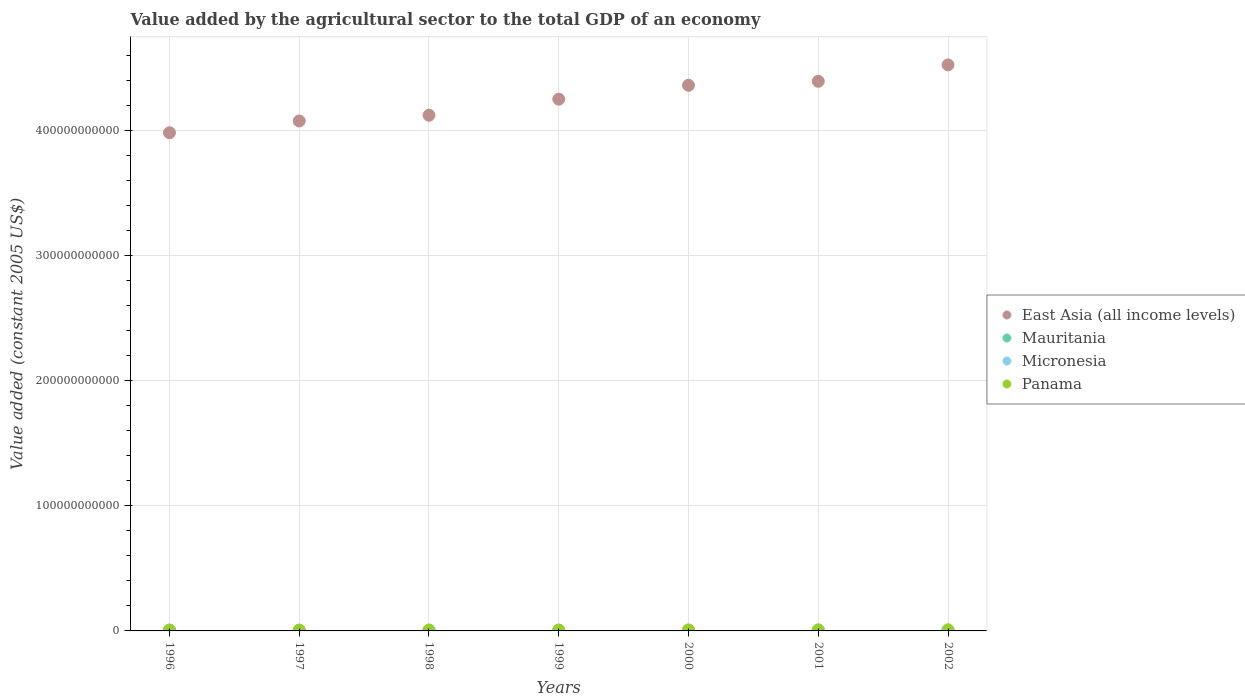What is the value added by the agricultural sector in Panama in 1999?
Provide a short and direct response. 7.35e+08. Across all years, what is the maximum value added by the agricultural sector in Mauritania?
Your answer should be very brief. 6.85e+08. Across all years, what is the minimum value added by the agricultural sector in Panama?
Give a very brief answer. 6.55e+08. In which year was the value added by the agricultural sector in East Asia (all income levels) maximum?
Give a very brief answer. 2002. What is the total value added by the agricultural sector in Mauritania in the graph?
Provide a short and direct response. 4.06e+09. What is the difference between the value added by the agricultural sector in East Asia (all income levels) in 1998 and that in 2001?
Offer a very short reply. -2.71e+1. What is the difference between the value added by the agricultural sector in Mauritania in 1999 and the value added by the agricultural sector in East Asia (all income levels) in 1996?
Provide a short and direct response. -3.97e+11. What is the average value added by the agricultural sector in Micronesia per year?
Provide a succinct answer. 5.56e+07. In the year 1997, what is the difference between the value added by the agricultural sector in East Asia (all income levels) and value added by the agricultural sector in Panama?
Ensure brevity in your answer.  4.07e+11. In how many years, is the value added by the agricultural sector in Micronesia greater than 180000000000 US$?
Provide a short and direct response. 0. What is the ratio of the value added by the agricultural sector in East Asia (all income levels) in 2000 to that in 2001?
Keep it short and to the point. 0.99. What is the difference between the highest and the second highest value added by the agricultural sector in Mauritania?
Give a very brief answer. 1.04e+08. What is the difference between the highest and the lowest value added by the agricultural sector in Panama?
Ensure brevity in your answer.  2.31e+08. Is the sum of the value added by the agricultural sector in Panama in 1999 and 2001 greater than the maximum value added by the agricultural sector in Mauritania across all years?
Your response must be concise. Yes. Does the value added by the agricultural sector in Mauritania monotonically increase over the years?
Your response must be concise. No. Is the value added by the agricultural sector in Panama strictly greater than the value added by the agricultural sector in East Asia (all income levels) over the years?
Your response must be concise. No. What is the difference between two consecutive major ticks on the Y-axis?
Ensure brevity in your answer.  1.00e+11. Does the graph contain any zero values?
Ensure brevity in your answer.  No. Does the graph contain grids?
Ensure brevity in your answer.  Yes. Where does the legend appear in the graph?
Give a very brief answer. Center right. How many legend labels are there?
Provide a succinct answer. 4. What is the title of the graph?
Make the answer very short. Value added by the agricultural sector to the total GDP of an economy. What is the label or title of the Y-axis?
Your response must be concise. Value added (constant 2005 US$). What is the Value added (constant 2005 US$) of East Asia (all income levels) in 1996?
Provide a short and direct response. 3.98e+11. What is the Value added (constant 2005 US$) in Mauritania in 1996?
Provide a short and direct response. 6.85e+08. What is the Value added (constant 2005 US$) of Micronesia in 1996?
Keep it short and to the point. 5.56e+07. What is the Value added (constant 2005 US$) of Panama in 1996?
Make the answer very short. 6.55e+08. What is the Value added (constant 2005 US$) in East Asia (all income levels) in 1997?
Offer a very short reply. 4.07e+11. What is the Value added (constant 2005 US$) in Mauritania in 1997?
Offer a terse response. 5.33e+08. What is the Value added (constant 2005 US$) of Micronesia in 1997?
Offer a terse response. 5.09e+07. What is the Value added (constant 2005 US$) of Panama in 1997?
Provide a short and direct response. 6.77e+08. What is the Value added (constant 2005 US$) of East Asia (all income levels) in 1998?
Keep it short and to the point. 4.12e+11. What is the Value added (constant 2005 US$) of Mauritania in 1998?
Your answer should be compact. 5.41e+08. What is the Value added (constant 2005 US$) of Micronesia in 1998?
Make the answer very short. 5.84e+07. What is the Value added (constant 2005 US$) of Panama in 1998?
Make the answer very short. 7.22e+08. What is the Value added (constant 2005 US$) in East Asia (all income levels) in 1999?
Keep it short and to the point. 4.25e+11. What is the Value added (constant 2005 US$) of Mauritania in 1999?
Ensure brevity in your answer.  5.81e+08. What is the Value added (constant 2005 US$) in Micronesia in 1999?
Give a very brief answer. 5.39e+07. What is the Value added (constant 2005 US$) in Panama in 1999?
Your answer should be compact. 7.35e+08. What is the Value added (constant 2005 US$) in East Asia (all income levels) in 2000?
Ensure brevity in your answer.  4.36e+11. What is the Value added (constant 2005 US$) of Mauritania in 2000?
Give a very brief answer. 5.76e+08. What is the Value added (constant 2005 US$) in Micronesia in 2000?
Make the answer very short. 5.76e+07. What is the Value added (constant 2005 US$) of Panama in 2000?
Offer a terse response. 8.05e+08. What is the Value added (constant 2005 US$) in East Asia (all income levels) in 2001?
Provide a succinct answer. 4.39e+11. What is the Value added (constant 2005 US$) in Mauritania in 2001?
Offer a very short reply. 5.81e+08. What is the Value added (constant 2005 US$) in Micronesia in 2001?
Offer a terse response. 5.57e+07. What is the Value added (constant 2005 US$) in Panama in 2001?
Your response must be concise. 8.57e+08. What is the Value added (constant 2005 US$) in East Asia (all income levels) in 2002?
Your answer should be compact. 4.52e+11. What is the Value added (constant 2005 US$) of Mauritania in 2002?
Keep it short and to the point. 5.64e+08. What is the Value added (constant 2005 US$) of Micronesia in 2002?
Provide a succinct answer. 5.68e+07. What is the Value added (constant 2005 US$) of Panama in 2002?
Make the answer very short. 8.86e+08. Across all years, what is the maximum Value added (constant 2005 US$) of East Asia (all income levels)?
Give a very brief answer. 4.52e+11. Across all years, what is the maximum Value added (constant 2005 US$) in Mauritania?
Offer a very short reply. 6.85e+08. Across all years, what is the maximum Value added (constant 2005 US$) of Micronesia?
Offer a terse response. 5.84e+07. Across all years, what is the maximum Value added (constant 2005 US$) in Panama?
Make the answer very short. 8.86e+08. Across all years, what is the minimum Value added (constant 2005 US$) of East Asia (all income levels)?
Your answer should be very brief. 3.98e+11. Across all years, what is the minimum Value added (constant 2005 US$) in Mauritania?
Provide a succinct answer. 5.33e+08. Across all years, what is the minimum Value added (constant 2005 US$) of Micronesia?
Ensure brevity in your answer.  5.09e+07. Across all years, what is the minimum Value added (constant 2005 US$) in Panama?
Make the answer very short. 6.55e+08. What is the total Value added (constant 2005 US$) in East Asia (all income levels) in the graph?
Your response must be concise. 2.97e+12. What is the total Value added (constant 2005 US$) of Mauritania in the graph?
Ensure brevity in your answer.  4.06e+09. What is the total Value added (constant 2005 US$) in Micronesia in the graph?
Offer a terse response. 3.89e+08. What is the total Value added (constant 2005 US$) of Panama in the graph?
Offer a terse response. 5.34e+09. What is the difference between the Value added (constant 2005 US$) in East Asia (all income levels) in 1996 and that in 1997?
Make the answer very short. -9.41e+09. What is the difference between the Value added (constant 2005 US$) in Mauritania in 1996 and that in 1997?
Your response must be concise. 1.52e+08. What is the difference between the Value added (constant 2005 US$) in Micronesia in 1996 and that in 1997?
Provide a succinct answer. 4.70e+06. What is the difference between the Value added (constant 2005 US$) of Panama in 1996 and that in 1997?
Ensure brevity in your answer.  -2.18e+07. What is the difference between the Value added (constant 2005 US$) in East Asia (all income levels) in 1996 and that in 1998?
Make the answer very short. -1.40e+1. What is the difference between the Value added (constant 2005 US$) of Mauritania in 1996 and that in 1998?
Provide a short and direct response. 1.44e+08. What is the difference between the Value added (constant 2005 US$) of Micronesia in 1996 and that in 1998?
Your response must be concise. -2.75e+06. What is the difference between the Value added (constant 2005 US$) in Panama in 1996 and that in 1998?
Provide a succinct answer. -6.66e+07. What is the difference between the Value added (constant 2005 US$) of East Asia (all income levels) in 1996 and that in 1999?
Ensure brevity in your answer.  -2.68e+1. What is the difference between the Value added (constant 2005 US$) in Mauritania in 1996 and that in 1999?
Your answer should be compact. 1.05e+08. What is the difference between the Value added (constant 2005 US$) of Micronesia in 1996 and that in 1999?
Give a very brief answer. 1.69e+06. What is the difference between the Value added (constant 2005 US$) of Panama in 1996 and that in 1999?
Offer a terse response. -7.96e+07. What is the difference between the Value added (constant 2005 US$) of East Asia (all income levels) in 1996 and that in 2000?
Keep it short and to the point. -3.79e+1. What is the difference between the Value added (constant 2005 US$) of Mauritania in 1996 and that in 2000?
Offer a very short reply. 1.10e+08. What is the difference between the Value added (constant 2005 US$) of Micronesia in 1996 and that in 2000?
Provide a short and direct response. -1.95e+06. What is the difference between the Value added (constant 2005 US$) in Panama in 1996 and that in 2000?
Keep it short and to the point. -1.50e+08. What is the difference between the Value added (constant 2005 US$) of East Asia (all income levels) in 1996 and that in 2001?
Keep it short and to the point. -4.11e+1. What is the difference between the Value added (constant 2005 US$) in Mauritania in 1996 and that in 2001?
Provide a short and direct response. 1.04e+08. What is the difference between the Value added (constant 2005 US$) in Micronesia in 1996 and that in 2001?
Offer a very short reply. -1.52e+04. What is the difference between the Value added (constant 2005 US$) of Panama in 1996 and that in 2001?
Your response must be concise. -2.02e+08. What is the difference between the Value added (constant 2005 US$) in East Asia (all income levels) in 1996 and that in 2002?
Make the answer very short. -5.42e+1. What is the difference between the Value added (constant 2005 US$) in Mauritania in 1996 and that in 2002?
Your response must be concise. 1.22e+08. What is the difference between the Value added (constant 2005 US$) in Micronesia in 1996 and that in 2002?
Ensure brevity in your answer.  -1.13e+06. What is the difference between the Value added (constant 2005 US$) of Panama in 1996 and that in 2002?
Make the answer very short. -2.31e+08. What is the difference between the Value added (constant 2005 US$) of East Asia (all income levels) in 1997 and that in 1998?
Your answer should be very brief. -4.57e+09. What is the difference between the Value added (constant 2005 US$) in Mauritania in 1997 and that in 1998?
Offer a very short reply. -7.94e+06. What is the difference between the Value added (constant 2005 US$) of Micronesia in 1997 and that in 1998?
Your answer should be compact. -7.45e+06. What is the difference between the Value added (constant 2005 US$) of Panama in 1997 and that in 1998?
Provide a succinct answer. -4.48e+07. What is the difference between the Value added (constant 2005 US$) in East Asia (all income levels) in 1997 and that in 1999?
Your answer should be very brief. -1.74e+1. What is the difference between the Value added (constant 2005 US$) in Mauritania in 1997 and that in 1999?
Provide a succinct answer. -4.75e+07. What is the difference between the Value added (constant 2005 US$) in Micronesia in 1997 and that in 1999?
Give a very brief answer. -3.01e+06. What is the difference between the Value added (constant 2005 US$) of Panama in 1997 and that in 1999?
Your answer should be very brief. -5.78e+07. What is the difference between the Value added (constant 2005 US$) of East Asia (all income levels) in 1997 and that in 2000?
Your response must be concise. -2.85e+1. What is the difference between the Value added (constant 2005 US$) of Mauritania in 1997 and that in 2000?
Offer a very short reply. -4.29e+07. What is the difference between the Value added (constant 2005 US$) of Micronesia in 1997 and that in 2000?
Provide a short and direct response. -6.65e+06. What is the difference between the Value added (constant 2005 US$) of Panama in 1997 and that in 2000?
Offer a terse response. -1.28e+08. What is the difference between the Value added (constant 2005 US$) in East Asia (all income levels) in 1997 and that in 2001?
Provide a short and direct response. -3.17e+1. What is the difference between the Value added (constant 2005 US$) of Mauritania in 1997 and that in 2001?
Give a very brief answer. -4.83e+07. What is the difference between the Value added (constant 2005 US$) in Micronesia in 1997 and that in 2001?
Provide a succinct answer. -4.72e+06. What is the difference between the Value added (constant 2005 US$) in Panama in 1997 and that in 2001?
Your answer should be very brief. -1.80e+08. What is the difference between the Value added (constant 2005 US$) in East Asia (all income levels) in 1997 and that in 2002?
Offer a terse response. -4.48e+1. What is the difference between the Value added (constant 2005 US$) in Mauritania in 1997 and that in 2002?
Keep it short and to the point. -3.05e+07. What is the difference between the Value added (constant 2005 US$) of Micronesia in 1997 and that in 2002?
Make the answer very short. -5.83e+06. What is the difference between the Value added (constant 2005 US$) in Panama in 1997 and that in 2002?
Offer a very short reply. -2.09e+08. What is the difference between the Value added (constant 2005 US$) of East Asia (all income levels) in 1998 and that in 1999?
Give a very brief answer. -1.28e+1. What is the difference between the Value added (constant 2005 US$) in Mauritania in 1998 and that in 1999?
Your answer should be compact. -3.96e+07. What is the difference between the Value added (constant 2005 US$) of Micronesia in 1998 and that in 1999?
Make the answer very short. 4.44e+06. What is the difference between the Value added (constant 2005 US$) in Panama in 1998 and that in 1999?
Offer a terse response. -1.29e+07. What is the difference between the Value added (constant 2005 US$) of East Asia (all income levels) in 1998 and that in 2000?
Provide a succinct answer. -2.39e+1. What is the difference between the Value added (constant 2005 US$) of Mauritania in 1998 and that in 2000?
Make the answer very short. -3.49e+07. What is the difference between the Value added (constant 2005 US$) in Micronesia in 1998 and that in 2000?
Provide a short and direct response. 7.99e+05. What is the difference between the Value added (constant 2005 US$) of Panama in 1998 and that in 2000?
Ensure brevity in your answer.  -8.34e+07. What is the difference between the Value added (constant 2005 US$) in East Asia (all income levels) in 1998 and that in 2001?
Your response must be concise. -2.71e+1. What is the difference between the Value added (constant 2005 US$) in Mauritania in 1998 and that in 2001?
Your answer should be compact. -4.03e+07. What is the difference between the Value added (constant 2005 US$) in Micronesia in 1998 and that in 2001?
Your answer should be very brief. 2.73e+06. What is the difference between the Value added (constant 2005 US$) in Panama in 1998 and that in 2001?
Your answer should be very brief. -1.35e+08. What is the difference between the Value added (constant 2005 US$) of East Asia (all income levels) in 1998 and that in 2002?
Give a very brief answer. -4.02e+1. What is the difference between the Value added (constant 2005 US$) in Mauritania in 1998 and that in 2002?
Offer a terse response. -2.25e+07. What is the difference between the Value added (constant 2005 US$) of Micronesia in 1998 and that in 2002?
Offer a terse response. 1.62e+06. What is the difference between the Value added (constant 2005 US$) in Panama in 1998 and that in 2002?
Keep it short and to the point. -1.64e+08. What is the difference between the Value added (constant 2005 US$) of East Asia (all income levels) in 1999 and that in 2000?
Your response must be concise. -1.11e+1. What is the difference between the Value added (constant 2005 US$) in Mauritania in 1999 and that in 2000?
Offer a very short reply. 4.62e+06. What is the difference between the Value added (constant 2005 US$) of Micronesia in 1999 and that in 2000?
Ensure brevity in your answer.  -3.64e+06. What is the difference between the Value added (constant 2005 US$) in Panama in 1999 and that in 2000?
Ensure brevity in your answer.  -7.05e+07. What is the difference between the Value added (constant 2005 US$) of East Asia (all income levels) in 1999 and that in 2001?
Give a very brief answer. -1.43e+1. What is the difference between the Value added (constant 2005 US$) in Mauritania in 1999 and that in 2001?
Give a very brief answer. -7.75e+05. What is the difference between the Value added (constant 2005 US$) of Micronesia in 1999 and that in 2001?
Offer a very short reply. -1.71e+06. What is the difference between the Value added (constant 2005 US$) in Panama in 1999 and that in 2001?
Provide a succinct answer. -1.23e+08. What is the difference between the Value added (constant 2005 US$) of East Asia (all income levels) in 1999 and that in 2002?
Your answer should be compact. -2.74e+1. What is the difference between the Value added (constant 2005 US$) in Mauritania in 1999 and that in 2002?
Provide a short and direct response. 1.70e+07. What is the difference between the Value added (constant 2005 US$) of Micronesia in 1999 and that in 2002?
Your response must be concise. -2.82e+06. What is the difference between the Value added (constant 2005 US$) in Panama in 1999 and that in 2002?
Ensure brevity in your answer.  -1.51e+08. What is the difference between the Value added (constant 2005 US$) of East Asia (all income levels) in 2000 and that in 2001?
Your answer should be compact. -3.18e+09. What is the difference between the Value added (constant 2005 US$) of Mauritania in 2000 and that in 2001?
Provide a short and direct response. -5.39e+06. What is the difference between the Value added (constant 2005 US$) of Micronesia in 2000 and that in 2001?
Ensure brevity in your answer.  1.94e+06. What is the difference between the Value added (constant 2005 US$) of Panama in 2000 and that in 2001?
Your response must be concise. -5.21e+07. What is the difference between the Value added (constant 2005 US$) of East Asia (all income levels) in 2000 and that in 2002?
Your answer should be very brief. -1.63e+1. What is the difference between the Value added (constant 2005 US$) of Mauritania in 2000 and that in 2002?
Your answer should be compact. 1.24e+07. What is the difference between the Value added (constant 2005 US$) in Micronesia in 2000 and that in 2002?
Offer a very short reply. 8.23e+05. What is the difference between the Value added (constant 2005 US$) of Panama in 2000 and that in 2002?
Provide a short and direct response. -8.06e+07. What is the difference between the Value added (constant 2005 US$) in East Asia (all income levels) in 2001 and that in 2002?
Keep it short and to the point. -1.31e+1. What is the difference between the Value added (constant 2005 US$) of Mauritania in 2001 and that in 2002?
Your response must be concise. 1.78e+07. What is the difference between the Value added (constant 2005 US$) in Micronesia in 2001 and that in 2002?
Ensure brevity in your answer.  -1.11e+06. What is the difference between the Value added (constant 2005 US$) of Panama in 2001 and that in 2002?
Offer a terse response. -2.85e+07. What is the difference between the Value added (constant 2005 US$) of East Asia (all income levels) in 1996 and the Value added (constant 2005 US$) of Mauritania in 1997?
Your answer should be compact. 3.97e+11. What is the difference between the Value added (constant 2005 US$) of East Asia (all income levels) in 1996 and the Value added (constant 2005 US$) of Micronesia in 1997?
Offer a terse response. 3.98e+11. What is the difference between the Value added (constant 2005 US$) in East Asia (all income levels) in 1996 and the Value added (constant 2005 US$) in Panama in 1997?
Provide a succinct answer. 3.97e+11. What is the difference between the Value added (constant 2005 US$) in Mauritania in 1996 and the Value added (constant 2005 US$) in Micronesia in 1997?
Offer a very short reply. 6.35e+08. What is the difference between the Value added (constant 2005 US$) in Mauritania in 1996 and the Value added (constant 2005 US$) in Panama in 1997?
Your answer should be compact. 8.34e+06. What is the difference between the Value added (constant 2005 US$) in Micronesia in 1996 and the Value added (constant 2005 US$) in Panama in 1997?
Ensure brevity in your answer.  -6.22e+08. What is the difference between the Value added (constant 2005 US$) of East Asia (all income levels) in 1996 and the Value added (constant 2005 US$) of Mauritania in 1998?
Your response must be concise. 3.97e+11. What is the difference between the Value added (constant 2005 US$) of East Asia (all income levels) in 1996 and the Value added (constant 2005 US$) of Micronesia in 1998?
Your response must be concise. 3.98e+11. What is the difference between the Value added (constant 2005 US$) in East Asia (all income levels) in 1996 and the Value added (constant 2005 US$) in Panama in 1998?
Give a very brief answer. 3.97e+11. What is the difference between the Value added (constant 2005 US$) of Mauritania in 1996 and the Value added (constant 2005 US$) of Micronesia in 1998?
Your answer should be very brief. 6.27e+08. What is the difference between the Value added (constant 2005 US$) of Mauritania in 1996 and the Value added (constant 2005 US$) of Panama in 1998?
Your answer should be very brief. -3.65e+07. What is the difference between the Value added (constant 2005 US$) of Micronesia in 1996 and the Value added (constant 2005 US$) of Panama in 1998?
Your response must be concise. -6.66e+08. What is the difference between the Value added (constant 2005 US$) of East Asia (all income levels) in 1996 and the Value added (constant 2005 US$) of Mauritania in 1999?
Offer a terse response. 3.97e+11. What is the difference between the Value added (constant 2005 US$) of East Asia (all income levels) in 1996 and the Value added (constant 2005 US$) of Micronesia in 1999?
Your response must be concise. 3.98e+11. What is the difference between the Value added (constant 2005 US$) in East Asia (all income levels) in 1996 and the Value added (constant 2005 US$) in Panama in 1999?
Make the answer very short. 3.97e+11. What is the difference between the Value added (constant 2005 US$) in Mauritania in 1996 and the Value added (constant 2005 US$) in Micronesia in 1999?
Your answer should be very brief. 6.32e+08. What is the difference between the Value added (constant 2005 US$) in Mauritania in 1996 and the Value added (constant 2005 US$) in Panama in 1999?
Offer a very short reply. -4.94e+07. What is the difference between the Value added (constant 2005 US$) of Micronesia in 1996 and the Value added (constant 2005 US$) of Panama in 1999?
Ensure brevity in your answer.  -6.79e+08. What is the difference between the Value added (constant 2005 US$) in East Asia (all income levels) in 1996 and the Value added (constant 2005 US$) in Mauritania in 2000?
Ensure brevity in your answer.  3.97e+11. What is the difference between the Value added (constant 2005 US$) in East Asia (all income levels) in 1996 and the Value added (constant 2005 US$) in Micronesia in 2000?
Make the answer very short. 3.98e+11. What is the difference between the Value added (constant 2005 US$) in East Asia (all income levels) in 1996 and the Value added (constant 2005 US$) in Panama in 2000?
Keep it short and to the point. 3.97e+11. What is the difference between the Value added (constant 2005 US$) of Mauritania in 1996 and the Value added (constant 2005 US$) of Micronesia in 2000?
Make the answer very short. 6.28e+08. What is the difference between the Value added (constant 2005 US$) of Mauritania in 1996 and the Value added (constant 2005 US$) of Panama in 2000?
Your answer should be very brief. -1.20e+08. What is the difference between the Value added (constant 2005 US$) in Micronesia in 1996 and the Value added (constant 2005 US$) in Panama in 2000?
Provide a short and direct response. -7.50e+08. What is the difference between the Value added (constant 2005 US$) in East Asia (all income levels) in 1996 and the Value added (constant 2005 US$) in Mauritania in 2001?
Offer a terse response. 3.97e+11. What is the difference between the Value added (constant 2005 US$) in East Asia (all income levels) in 1996 and the Value added (constant 2005 US$) in Micronesia in 2001?
Provide a short and direct response. 3.98e+11. What is the difference between the Value added (constant 2005 US$) in East Asia (all income levels) in 1996 and the Value added (constant 2005 US$) in Panama in 2001?
Offer a terse response. 3.97e+11. What is the difference between the Value added (constant 2005 US$) in Mauritania in 1996 and the Value added (constant 2005 US$) in Micronesia in 2001?
Offer a very short reply. 6.30e+08. What is the difference between the Value added (constant 2005 US$) of Mauritania in 1996 and the Value added (constant 2005 US$) of Panama in 2001?
Offer a very short reply. -1.72e+08. What is the difference between the Value added (constant 2005 US$) of Micronesia in 1996 and the Value added (constant 2005 US$) of Panama in 2001?
Provide a succinct answer. -8.02e+08. What is the difference between the Value added (constant 2005 US$) in East Asia (all income levels) in 1996 and the Value added (constant 2005 US$) in Mauritania in 2002?
Your response must be concise. 3.97e+11. What is the difference between the Value added (constant 2005 US$) in East Asia (all income levels) in 1996 and the Value added (constant 2005 US$) in Micronesia in 2002?
Keep it short and to the point. 3.98e+11. What is the difference between the Value added (constant 2005 US$) of East Asia (all income levels) in 1996 and the Value added (constant 2005 US$) of Panama in 2002?
Provide a short and direct response. 3.97e+11. What is the difference between the Value added (constant 2005 US$) in Mauritania in 1996 and the Value added (constant 2005 US$) in Micronesia in 2002?
Your answer should be very brief. 6.29e+08. What is the difference between the Value added (constant 2005 US$) in Mauritania in 1996 and the Value added (constant 2005 US$) in Panama in 2002?
Ensure brevity in your answer.  -2.00e+08. What is the difference between the Value added (constant 2005 US$) of Micronesia in 1996 and the Value added (constant 2005 US$) of Panama in 2002?
Your answer should be very brief. -8.30e+08. What is the difference between the Value added (constant 2005 US$) of East Asia (all income levels) in 1997 and the Value added (constant 2005 US$) of Mauritania in 1998?
Give a very brief answer. 4.07e+11. What is the difference between the Value added (constant 2005 US$) in East Asia (all income levels) in 1997 and the Value added (constant 2005 US$) in Micronesia in 1998?
Provide a succinct answer. 4.07e+11. What is the difference between the Value added (constant 2005 US$) of East Asia (all income levels) in 1997 and the Value added (constant 2005 US$) of Panama in 1998?
Your answer should be compact. 4.07e+11. What is the difference between the Value added (constant 2005 US$) of Mauritania in 1997 and the Value added (constant 2005 US$) of Micronesia in 1998?
Make the answer very short. 4.75e+08. What is the difference between the Value added (constant 2005 US$) in Mauritania in 1997 and the Value added (constant 2005 US$) in Panama in 1998?
Give a very brief answer. -1.89e+08. What is the difference between the Value added (constant 2005 US$) of Micronesia in 1997 and the Value added (constant 2005 US$) of Panama in 1998?
Ensure brevity in your answer.  -6.71e+08. What is the difference between the Value added (constant 2005 US$) in East Asia (all income levels) in 1997 and the Value added (constant 2005 US$) in Mauritania in 1999?
Offer a very short reply. 4.07e+11. What is the difference between the Value added (constant 2005 US$) of East Asia (all income levels) in 1997 and the Value added (constant 2005 US$) of Micronesia in 1999?
Your answer should be very brief. 4.07e+11. What is the difference between the Value added (constant 2005 US$) in East Asia (all income levels) in 1997 and the Value added (constant 2005 US$) in Panama in 1999?
Provide a short and direct response. 4.07e+11. What is the difference between the Value added (constant 2005 US$) of Mauritania in 1997 and the Value added (constant 2005 US$) of Micronesia in 1999?
Make the answer very short. 4.79e+08. What is the difference between the Value added (constant 2005 US$) in Mauritania in 1997 and the Value added (constant 2005 US$) in Panama in 1999?
Your answer should be very brief. -2.02e+08. What is the difference between the Value added (constant 2005 US$) of Micronesia in 1997 and the Value added (constant 2005 US$) of Panama in 1999?
Provide a succinct answer. -6.84e+08. What is the difference between the Value added (constant 2005 US$) in East Asia (all income levels) in 1997 and the Value added (constant 2005 US$) in Mauritania in 2000?
Give a very brief answer. 4.07e+11. What is the difference between the Value added (constant 2005 US$) of East Asia (all income levels) in 1997 and the Value added (constant 2005 US$) of Micronesia in 2000?
Offer a terse response. 4.07e+11. What is the difference between the Value added (constant 2005 US$) in East Asia (all income levels) in 1997 and the Value added (constant 2005 US$) in Panama in 2000?
Give a very brief answer. 4.07e+11. What is the difference between the Value added (constant 2005 US$) of Mauritania in 1997 and the Value added (constant 2005 US$) of Micronesia in 2000?
Your response must be concise. 4.76e+08. What is the difference between the Value added (constant 2005 US$) in Mauritania in 1997 and the Value added (constant 2005 US$) in Panama in 2000?
Offer a terse response. -2.72e+08. What is the difference between the Value added (constant 2005 US$) in Micronesia in 1997 and the Value added (constant 2005 US$) in Panama in 2000?
Your answer should be compact. -7.54e+08. What is the difference between the Value added (constant 2005 US$) of East Asia (all income levels) in 1997 and the Value added (constant 2005 US$) of Mauritania in 2001?
Provide a short and direct response. 4.07e+11. What is the difference between the Value added (constant 2005 US$) of East Asia (all income levels) in 1997 and the Value added (constant 2005 US$) of Micronesia in 2001?
Offer a terse response. 4.07e+11. What is the difference between the Value added (constant 2005 US$) in East Asia (all income levels) in 1997 and the Value added (constant 2005 US$) in Panama in 2001?
Offer a very short reply. 4.06e+11. What is the difference between the Value added (constant 2005 US$) of Mauritania in 1997 and the Value added (constant 2005 US$) of Micronesia in 2001?
Keep it short and to the point. 4.77e+08. What is the difference between the Value added (constant 2005 US$) of Mauritania in 1997 and the Value added (constant 2005 US$) of Panama in 2001?
Your answer should be very brief. -3.24e+08. What is the difference between the Value added (constant 2005 US$) in Micronesia in 1997 and the Value added (constant 2005 US$) in Panama in 2001?
Make the answer very short. -8.07e+08. What is the difference between the Value added (constant 2005 US$) in East Asia (all income levels) in 1997 and the Value added (constant 2005 US$) in Mauritania in 2002?
Provide a short and direct response. 4.07e+11. What is the difference between the Value added (constant 2005 US$) of East Asia (all income levels) in 1997 and the Value added (constant 2005 US$) of Micronesia in 2002?
Offer a terse response. 4.07e+11. What is the difference between the Value added (constant 2005 US$) of East Asia (all income levels) in 1997 and the Value added (constant 2005 US$) of Panama in 2002?
Your answer should be very brief. 4.06e+11. What is the difference between the Value added (constant 2005 US$) in Mauritania in 1997 and the Value added (constant 2005 US$) in Micronesia in 2002?
Give a very brief answer. 4.76e+08. What is the difference between the Value added (constant 2005 US$) of Mauritania in 1997 and the Value added (constant 2005 US$) of Panama in 2002?
Provide a short and direct response. -3.53e+08. What is the difference between the Value added (constant 2005 US$) of Micronesia in 1997 and the Value added (constant 2005 US$) of Panama in 2002?
Your response must be concise. -8.35e+08. What is the difference between the Value added (constant 2005 US$) of East Asia (all income levels) in 1998 and the Value added (constant 2005 US$) of Mauritania in 1999?
Your response must be concise. 4.11e+11. What is the difference between the Value added (constant 2005 US$) in East Asia (all income levels) in 1998 and the Value added (constant 2005 US$) in Micronesia in 1999?
Offer a very short reply. 4.12e+11. What is the difference between the Value added (constant 2005 US$) in East Asia (all income levels) in 1998 and the Value added (constant 2005 US$) in Panama in 1999?
Your answer should be compact. 4.11e+11. What is the difference between the Value added (constant 2005 US$) in Mauritania in 1998 and the Value added (constant 2005 US$) in Micronesia in 1999?
Provide a short and direct response. 4.87e+08. What is the difference between the Value added (constant 2005 US$) of Mauritania in 1998 and the Value added (constant 2005 US$) of Panama in 1999?
Your answer should be compact. -1.94e+08. What is the difference between the Value added (constant 2005 US$) in Micronesia in 1998 and the Value added (constant 2005 US$) in Panama in 1999?
Ensure brevity in your answer.  -6.77e+08. What is the difference between the Value added (constant 2005 US$) in East Asia (all income levels) in 1998 and the Value added (constant 2005 US$) in Mauritania in 2000?
Ensure brevity in your answer.  4.11e+11. What is the difference between the Value added (constant 2005 US$) in East Asia (all income levels) in 1998 and the Value added (constant 2005 US$) in Micronesia in 2000?
Your response must be concise. 4.12e+11. What is the difference between the Value added (constant 2005 US$) of East Asia (all income levels) in 1998 and the Value added (constant 2005 US$) of Panama in 2000?
Your answer should be very brief. 4.11e+11. What is the difference between the Value added (constant 2005 US$) of Mauritania in 1998 and the Value added (constant 2005 US$) of Micronesia in 2000?
Provide a succinct answer. 4.83e+08. What is the difference between the Value added (constant 2005 US$) in Mauritania in 1998 and the Value added (constant 2005 US$) in Panama in 2000?
Keep it short and to the point. -2.64e+08. What is the difference between the Value added (constant 2005 US$) of Micronesia in 1998 and the Value added (constant 2005 US$) of Panama in 2000?
Provide a short and direct response. -7.47e+08. What is the difference between the Value added (constant 2005 US$) of East Asia (all income levels) in 1998 and the Value added (constant 2005 US$) of Mauritania in 2001?
Offer a terse response. 4.11e+11. What is the difference between the Value added (constant 2005 US$) of East Asia (all income levels) in 1998 and the Value added (constant 2005 US$) of Micronesia in 2001?
Keep it short and to the point. 4.12e+11. What is the difference between the Value added (constant 2005 US$) in East Asia (all income levels) in 1998 and the Value added (constant 2005 US$) in Panama in 2001?
Offer a terse response. 4.11e+11. What is the difference between the Value added (constant 2005 US$) of Mauritania in 1998 and the Value added (constant 2005 US$) of Micronesia in 2001?
Your answer should be compact. 4.85e+08. What is the difference between the Value added (constant 2005 US$) of Mauritania in 1998 and the Value added (constant 2005 US$) of Panama in 2001?
Make the answer very short. -3.16e+08. What is the difference between the Value added (constant 2005 US$) of Micronesia in 1998 and the Value added (constant 2005 US$) of Panama in 2001?
Provide a succinct answer. -7.99e+08. What is the difference between the Value added (constant 2005 US$) in East Asia (all income levels) in 1998 and the Value added (constant 2005 US$) in Mauritania in 2002?
Make the answer very short. 4.11e+11. What is the difference between the Value added (constant 2005 US$) of East Asia (all income levels) in 1998 and the Value added (constant 2005 US$) of Micronesia in 2002?
Your answer should be very brief. 4.12e+11. What is the difference between the Value added (constant 2005 US$) in East Asia (all income levels) in 1998 and the Value added (constant 2005 US$) in Panama in 2002?
Give a very brief answer. 4.11e+11. What is the difference between the Value added (constant 2005 US$) in Mauritania in 1998 and the Value added (constant 2005 US$) in Micronesia in 2002?
Offer a very short reply. 4.84e+08. What is the difference between the Value added (constant 2005 US$) in Mauritania in 1998 and the Value added (constant 2005 US$) in Panama in 2002?
Keep it short and to the point. -3.45e+08. What is the difference between the Value added (constant 2005 US$) in Micronesia in 1998 and the Value added (constant 2005 US$) in Panama in 2002?
Your answer should be compact. -8.28e+08. What is the difference between the Value added (constant 2005 US$) in East Asia (all income levels) in 1999 and the Value added (constant 2005 US$) in Mauritania in 2000?
Your answer should be very brief. 4.24e+11. What is the difference between the Value added (constant 2005 US$) in East Asia (all income levels) in 1999 and the Value added (constant 2005 US$) in Micronesia in 2000?
Provide a succinct answer. 4.25e+11. What is the difference between the Value added (constant 2005 US$) of East Asia (all income levels) in 1999 and the Value added (constant 2005 US$) of Panama in 2000?
Provide a short and direct response. 4.24e+11. What is the difference between the Value added (constant 2005 US$) of Mauritania in 1999 and the Value added (constant 2005 US$) of Micronesia in 2000?
Provide a succinct answer. 5.23e+08. What is the difference between the Value added (constant 2005 US$) of Mauritania in 1999 and the Value added (constant 2005 US$) of Panama in 2000?
Ensure brevity in your answer.  -2.25e+08. What is the difference between the Value added (constant 2005 US$) in Micronesia in 1999 and the Value added (constant 2005 US$) in Panama in 2000?
Provide a succinct answer. -7.51e+08. What is the difference between the Value added (constant 2005 US$) of East Asia (all income levels) in 1999 and the Value added (constant 2005 US$) of Mauritania in 2001?
Your answer should be compact. 4.24e+11. What is the difference between the Value added (constant 2005 US$) in East Asia (all income levels) in 1999 and the Value added (constant 2005 US$) in Micronesia in 2001?
Give a very brief answer. 4.25e+11. What is the difference between the Value added (constant 2005 US$) of East Asia (all income levels) in 1999 and the Value added (constant 2005 US$) of Panama in 2001?
Provide a short and direct response. 4.24e+11. What is the difference between the Value added (constant 2005 US$) of Mauritania in 1999 and the Value added (constant 2005 US$) of Micronesia in 2001?
Provide a succinct answer. 5.25e+08. What is the difference between the Value added (constant 2005 US$) in Mauritania in 1999 and the Value added (constant 2005 US$) in Panama in 2001?
Give a very brief answer. -2.77e+08. What is the difference between the Value added (constant 2005 US$) in Micronesia in 1999 and the Value added (constant 2005 US$) in Panama in 2001?
Give a very brief answer. -8.04e+08. What is the difference between the Value added (constant 2005 US$) in East Asia (all income levels) in 1999 and the Value added (constant 2005 US$) in Mauritania in 2002?
Give a very brief answer. 4.24e+11. What is the difference between the Value added (constant 2005 US$) of East Asia (all income levels) in 1999 and the Value added (constant 2005 US$) of Micronesia in 2002?
Offer a very short reply. 4.25e+11. What is the difference between the Value added (constant 2005 US$) of East Asia (all income levels) in 1999 and the Value added (constant 2005 US$) of Panama in 2002?
Offer a terse response. 4.24e+11. What is the difference between the Value added (constant 2005 US$) of Mauritania in 1999 and the Value added (constant 2005 US$) of Micronesia in 2002?
Your answer should be compact. 5.24e+08. What is the difference between the Value added (constant 2005 US$) of Mauritania in 1999 and the Value added (constant 2005 US$) of Panama in 2002?
Offer a terse response. -3.05e+08. What is the difference between the Value added (constant 2005 US$) in Micronesia in 1999 and the Value added (constant 2005 US$) in Panama in 2002?
Your answer should be compact. -8.32e+08. What is the difference between the Value added (constant 2005 US$) of East Asia (all income levels) in 2000 and the Value added (constant 2005 US$) of Mauritania in 2001?
Your answer should be compact. 4.35e+11. What is the difference between the Value added (constant 2005 US$) in East Asia (all income levels) in 2000 and the Value added (constant 2005 US$) in Micronesia in 2001?
Provide a succinct answer. 4.36e+11. What is the difference between the Value added (constant 2005 US$) of East Asia (all income levels) in 2000 and the Value added (constant 2005 US$) of Panama in 2001?
Your response must be concise. 4.35e+11. What is the difference between the Value added (constant 2005 US$) in Mauritania in 2000 and the Value added (constant 2005 US$) in Micronesia in 2001?
Give a very brief answer. 5.20e+08. What is the difference between the Value added (constant 2005 US$) in Mauritania in 2000 and the Value added (constant 2005 US$) in Panama in 2001?
Offer a very short reply. -2.82e+08. What is the difference between the Value added (constant 2005 US$) of Micronesia in 2000 and the Value added (constant 2005 US$) of Panama in 2001?
Your response must be concise. -8.00e+08. What is the difference between the Value added (constant 2005 US$) of East Asia (all income levels) in 2000 and the Value added (constant 2005 US$) of Mauritania in 2002?
Offer a terse response. 4.35e+11. What is the difference between the Value added (constant 2005 US$) in East Asia (all income levels) in 2000 and the Value added (constant 2005 US$) in Micronesia in 2002?
Make the answer very short. 4.36e+11. What is the difference between the Value added (constant 2005 US$) of East Asia (all income levels) in 2000 and the Value added (constant 2005 US$) of Panama in 2002?
Your answer should be compact. 4.35e+11. What is the difference between the Value added (constant 2005 US$) in Mauritania in 2000 and the Value added (constant 2005 US$) in Micronesia in 2002?
Provide a succinct answer. 5.19e+08. What is the difference between the Value added (constant 2005 US$) in Mauritania in 2000 and the Value added (constant 2005 US$) in Panama in 2002?
Ensure brevity in your answer.  -3.10e+08. What is the difference between the Value added (constant 2005 US$) in Micronesia in 2000 and the Value added (constant 2005 US$) in Panama in 2002?
Offer a very short reply. -8.28e+08. What is the difference between the Value added (constant 2005 US$) of East Asia (all income levels) in 2001 and the Value added (constant 2005 US$) of Mauritania in 2002?
Give a very brief answer. 4.38e+11. What is the difference between the Value added (constant 2005 US$) in East Asia (all income levels) in 2001 and the Value added (constant 2005 US$) in Micronesia in 2002?
Keep it short and to the point. 4.39e+11. What is the difference between the Value added (constant 2005 US$) in East Asia (all income levels) in 2001 and the Value added (constant 2005 US$) in Panama in 2002?
Keep it short and to the point. 4.38e+11. What is the difference between the Value added (constant 2005 US$) of Mauritania in 2001 and the Value added (constant 2005 US$) of Micronesia in 2002?
Provide a short and direct response. 5.25e+08. What is the difference between the Value added (constant 2005 US$) in Mauritania in 2001 and the Value added (constant 2005 US$) in Panama in 2002?
Provide a short and direct response. -3.05e+08. What is the difference between the Value added (constant 2005 US$) of Micronesia in 2001 and the Value added (constant 2005 US$) of Panama in 2002?
Your answer should be compact. -8.30e+08. What is the average Value added (constant 2005 US$) of East Asia (all income levels) per year?
Give a very brief answer. 4.24e+11. What is the average Value added (constant 2005 US$) in Mauritania per year?
Your response must be concise. 5.80e+08. What is the average Value added (constant 2005 US$) of Micronesia per year?
Your answer should be very brief. 5.56e+07. What is the average Value added (constant 2005 US$) of Panama per year?
Make the answer very short. 7.63e+08. In the year 1996, what is the difference between the Value added (constant 2005 US$) of East Asia (all income levels) and Value added (constant 2005 US$) of Mauritania?
Keep it short and to the point. 3.97e+11. In the year 1996, what is the difference between the Value added (constant 2005 US$) in East Asia (all income levels) and Value added (constant 2005 US$) in Micronesia?
Ensure brevity in your answer.  3.98e+11. In the year 1996, what is the difference between the Value added (constant 2005 US$) in East Asia (all income levels) and Value added (constant 2005 US$) in Panama?
Give a very brief answer. 3.97e+11. In the year 1996, what is the difference between the Value added (constant 2005 US$) in Mauritania and Value added (constant 2005 US$) in Micronesia?
Your answer should be compact. 6.30e+08. In the year 1996, what is the difference between the Value added (constant 2005 US$) of Mauritania and Value added (constant 2005 US$) of Panama?
Your response must be concise. 3.01e+07. In the year 1996, what is the difference between the Value added (constant 2005 US$) of Micronesia and Value added (constant 2005 US$) of Panama?
Provide a succinct answer. -6.00e+08. In the year 1997, what is the difference between the Value added (constant 2005 US$) of East Asia (all income levels) and Value added (constant 2005 US$) of Mauritania?
Offer a terse response. 4.07e+11. In the year 1997, what is the difference between the Value added (constant 2005 US$) in East Asia (all income levels) and Value added (constant 2005 US$) in Micronesia?
Keep it short and to the point. 4.07e+11. In the year 1997, what is the difference between the Value added (constant 2005 US$) in East Asia (all income levels) and Value added (constant 2005 US$) in Panama?
Your response must be concise. 4.07e+11. In the year 1997, what is the difference between the Value added (constant 2005 US$) of Mauritania and Value added (constant 2005 US$) of Micronesia?
Your response must be concise. 4.82e+08. In the year 1997, what is the difference between the Value added (constant 2005 US$) in Mauritania and Value added (constant 2005 US$) in Panama?
Give a very brief answer. -1.44e+08. In the year 1997, what is the difference between the Value added (constant 2005 US$) in Micronesia and Value added (constant 2005 US$) in Panama?
Your response must be concise. -6.26e+08. In the year 1998, what is the difference between the Value added (constant 2005 US$) in East Asia (all income levels) and Value added (constant 2005 US$) in Mauritania?
Keep it short and to the point. 4.11e+11. In the year 1998, what is the difference between the Value added (constant 2005 US$) in East Asia (all income levels) and Value added (constant 2005 US$) in Micronesia?
Your answer should be very brief. 4.12e+11. In the year 1998, what is the difference between the Value added (constant 2005 US$) of East Asia (all income levels) and Value added (constant 2005 US$) of Panama?
Your response must be concise. 4.11e+11. In the year 1998, what is the difference between the Value added (constant 2005 US$) in Mauritania and Value added (constant 2005 US$) in Micronesia?
Offer a terse response. 4.83e+08. In the year 1998, what is the difference between the Value added (constant 2005 US$) of Mauritania and Value added (constant 2005 US$) of Panama?
Offer a very short reply. -1.81e+08. In the year 1998, what is the difference between the Value added (constant 2005 US$) in Micronesia and Value added (constant 2005 US$) in Panama?
Give a very brief answer. -6.64e+08. In the year 1999, what is the difference between the Value added (constant 2005 US$) in East Asia (all income levels) and Value added (constant 2005 US$) in Mauritania?
Give a very brief answer. 4.24e+11. In the year 1999, what is the difference between the Value added (constant 2005 US$) of East Asia (all income levels) and Value added (constant 2005 US$) of Micronesia?
Keep it short and to the point. 4.25e+11. In the year 1999, what is the difference between the Value added (constant 2005 US$) in East Asia (all income levels) and Value added (constant 2005 US$) in Panama?
Give a very brief answer. 4.24e+11. In the year 1999, what is the difference between the Value added (constant 2005 US$) of Mauritania and Value added (constant 2005 US$) of Micronesia?
Ensure brevity in your answer.  5.27e+08. In the year 1999, what is the difference between the Value added (constant 2005 US$) in Mauritania and Value added (constant 2005 US$) in Panama?
Your response must be concise. -1.54e+08. In the year 1999, what is the difference between the Value added (constant 2005 US$) in Micronesia and Value added (constant 2005 US$) in Panama?
Provide a succinct answer. -6.81e+08. In the year 2000, what is the difference between the Value added (constant 2005 US$) in East Asia (all income levels) and Value added (constant 2005 US$) in Mauritania?
Offer a terse response. 4.35e+11. In the year 2000, what is the difference between the Value added (constant 2005 US$) of East Asia (all income levels) and Value added (constant 2005 US$) of Micronesia?
Make the answer very short. 4.36e+11. In the year 2000, what is the difference between the Value added (constant 2005 US$) of East Asia (all income levels) and Value added (constant 2005 US$) of Panama?
Your answer should be very brief. 4.35e+11. In the year 2000, what is the difference between the Value added (constant 2005 US$) of Mauritania and Value added (constant 2005 US$) of Micronesia?
Your answer should be very brief. 5.18e+08. In the year 2000, what is the difference between the Value added (constant 2005 US$) in Mauritania and Value added (constant 2005 US$) in Panama?
Offer a very short reply. -2.29e+08. In the year 2000, what is the difference between the Value added (constant 2005 US$) of Micronesia and Value added (constant 2005 US$) of Panama?
Make the answer very short. -7.48e+08. In the year 2001, what is the difference between the Value added (constant 2005 US$) in East Asia (all income levels) and Value added (constant 2005 US$) in Mauritania?
Provide a succinct answer. 4.38e+11. In the year 2001, what is the difference between the Value added (constant 2005 US$) of East Asia (all income levels) and Value added (constant 2005 US$) of Micronesia?
Give a very brief answer. 4.39e+11. In the year 2001, what is the difference between the Value added (constant 2005 US$) in East Asia (all income levels) and Value added (constant 2005 US$) in Panama?
Offer a terse response. 4.38e+11. In the year 2001, what is the difference between the Value added (constant 2005 US$) in Mauritania and Value added (constant 2005 US$) in Micronesia?
Your answer should be compact. 5.26e+08. In the year 2001, what is the difference between the Value added (constant 2005 US$) in Mauritania and Value added (constant 2005 US$) in Panama?
Provide a succinct answer. -2.76e+08. In the year 2001, what is the difference between the Value added (constant 2005 US$) of Micronesia and Value added (constant 2005 US$) of Panama?
Offer a terse response. -8.02e+08. In the year 2002, what is the difference between the Value added (constant 2005 US$) in East Asia (all income levels) and Value added (constant 2005 US$) in Mauritania?
Your answer should be compact. 4.52e+11. In the year 2002, what is the difference between the Value added (constant 2005 US$) in East Asia (all income levels) and Value added (constant 2005 US$) in Micronesia?
Keep it short and to the point. 4.52e+11. In the year 2002, what is the difference between the Value added (constant 2005 US$) in East Asia (all income levels) and Value added (constant 2005 US$) in Panama?
Provide a short and direct response. 4.51e+11. In the year 2002, what is the difference between the Value added (constant 2005 US$) in Mauritania and Value added (constant 2005 US$) in Micronesia?
Your answer should be compact. 5.07e+08. In the year 2002, what is the difference between the Value added (constant 2005 US$) in Mauritania and Value added (constant 2005 US$) in Panama?
Provide a succinct answer. -3.22e+08. In the year 2002, what is the difference between the Value added (constant 2005 US$) of Micronesia and Value added (constant 2005 US$) of Panama?
Provide a succinct answer. -8.29e+08. What is the ratio of the Value added (constant 2005 US$) of East Asia (all income levels) in 1996 to that in 1997?
Offer a terse response. 0.98. What is the ratio of the Value added (constant 2005 US$) in Mauritania in 1996 to that in 1997?
Give a very brief answer. 1.29. What is the ratio of the Value added (constant 2005 US$) in Micronesia in 1996 to that in 1997?
Your answer should be compact. 1.09. What is the ratio of the Value added (constant 2005 US$) of Panama in 1996 to that in 1997?
Keep it short and to the point. 0.97. What is the ratio of the Value added (constant 2005 US$) of East Asia (all income levels) in 1996 to that in 1998?
Make the answer very short. 0.97. What is the ratio of the Value added (constant 2005 US$) in Mauritania in 1996 to that in 1998?
Your answer should be very brief. 1.27. What is the ratio of the Value added (constant 2005 US$) in Micronesia in 1996 to that in 1998?
Offer a terse response. 0.95. What is the ratio of the Value added (constant 2005 US$) of Panama in 1996 to that in 1998?
Your response must be concise. 0.91. What is the ratio of the Value added (constant 2005 US$) of East Asia (all income levels) in 1996 to that in 1999?
Ensure brevity in your answer.  0.94. What is the ratio of the Value added (constant 2005 US$) of Mauritania in 1996 to that in 1999?
Your response must be concise. 1.18. What is the ratio of the Value added (constant 2005 US$) of Micronesia in 1996 to that in 1999?
Your response must be concise. 1.03. What is the ratio of the Value added (constant 2005 US$) in Panama in 1996 to that in 1999?
Your response must be concise. 0.89. What is the ratio of the Value added (constant 2005 US$) of Mauritania in 1996 to that in 2000?
Ensure brevity in your answer.  1.19. What is the ratio of the Value added (constant 2005 US$) of Micronesia in 1996 to that in 2000?
Offer a very short reply. 0.97. What is the ratio of the Value added (constant 2005 US$) in Panama in 1996 to that in 2000?
Your answer should be very brief. 0.81. What is the ratio of the Value added (constant 2005 US$) in East Asia (all income levels) in 1996 to that in 2001?
Offer a terse response. 0.91. What is the ratio of the Value added (constant 2005 US$) of Mauritania in 1996 to that in 2001?
Make the answer very short. 1.18. What is the ratio of the Value added (constant 2005 US$) of Micronesia in 1996 to that in 2001?
Offer a very short reply. 1. What is the ratio of the Value added (constant 2005 US$) of Panama in 1996 to that in 2001?
Make the answer very short. 0.76. What is the ratio of the Value added (constant 2005 US$) in East Asia (all income levels) in 1996 to that in 2002?
Offer a terse response. 0.88. What is the ratio of the Value added (constant 2005 US$) of Mauritania in 1996 to that in 2002?
Make the answer very short. 1.22. What is the ratio of the Value added (constant 2005 US$) in Micronesia in 1996 to that in 2002?
Ensure brevity in your answer.  0.98. What is the ratio of the Value added (constant 2005 US$) of Panama in 1996 to that in 2002?
Give a very brief answer. 0.74. What is the ratio of the Value added (constant 2005 US$) of East Asia (all income levels) in 1997 to that in 1998?
Offer a terse response. 0.99. What is the ratio of the Value added (constant 2005 US$) in Mauritania in 1997 to that in 1998?
Your response must be concise. 0.99. What is the ratio of the Value added (constant 2005 US$) in Micronesia in 1997 to that in 1998?
Offer a very short reply. 0.87. What is the ratio of the Value added (constant 2005 US$) of Panama in 1997 to that in 1998?
Make the answer very short. 0.94. What is the ratio of the Value added (constant 2005 US$) in East Asia (all income levels) in 1997 to that in 1999?
Your answer should be compact. 0.96. What is the ratio of the Value added (constant 2005 US$) in Mauritania in 1997 to that in 1999?
Your answer should be compact. 0.92. What is the ratio of the Value added (constant 2005 US$) in Micronesia in 1997 to that in 1999?
Ensure brevity in your answer.  0.94. What is the ratio of the Value added (constant 2005 US$) in Panama in 1997 to that in 1999?
Keep it short and to the point. 0.92. What is the ratio of the Value added (constant 2005 US$) of East Asia (all income levels) in 1997 to that in 2000?
Your answer should be very brief. 0.93. What is the ratio of the Value added (constant 2005 US$) of Mauritania in 1997 to that in 2000?
Your answer should be compact. 0.93. What is the ratio of the Value added (constant 2005 US$) of Micronesia in 1997 to that in 2000?
Provide a succinct answer. 0.88. What is the ratio of the Value added (constant 2005 US$) in Panama in 1997 to that in 2000?
Your response must be concise. 0.84. What is the ratio of the Value added (constant 2005 US$) of East Asia (all income levels) in 1997 to that in 2001?
Offer a terse response. 0.93. What is the ratio of the Value added (constant 2005 US$) of Mauritania in 1997 to that in 2001?
Provide a succinct answer. 0.92. What is the ratio of the Value added (constant 2005 US$) of Micronesia in 1997 to that in 2001?
Provide a succinct answer. 0.92. What is the ratio of the Value added (constant 2005 US$) in Panama in 1997 to that in 2001?
Provide a short and direct response. 0.79. What is the ratio of the Value added (constant 2005 US$) of East Asia (all income levels) in 1997 to that in 2002?
Make the answer very short. 0.9. What is the ratio of the Value added (constant 2005 US$) in Mauritania in 1997 to that in 2002?
Ensure brevity in your answer.  0.95. What is the ratio of the Value added (constant 2005 US$) of Micronesia in 1997 to that in 2002?
Keep it short and to the point. 0.9. What is the ratio of the Value added (constant 2005 US$) of Panama in 1997 to that in 2002?
Provide a short and direct response. 0.76. What is the ratio of the Value added (constant 2005 US$) of East Asia (all income levels) in 1998 to that in 1999?
Your answer should be very brief. 0.97. What is the ratio of the Value added (constant 2005 US$) of Mauritania in 1998 to that in 1999?
Ensure brevity in your answer.  0.93. What is the ratio of the Value added (constant 2005 US$) of Micronesia in 1998 to that in 1999?
Make the answer very short. 1.08. What is the ratio of the Value added (constant 2005 US$) of Panama in 1998 to that in 1999?
Ensure brevity in your answer.  0.98. What is the ratio of the Value added (constant 2005 US$) in East Asia (all income levels) in 1998 to that in 2000?
Provide a short and direct response. 0.95. What is the ratio of the Value added (constant 2005 US$) of Mauritania in 1998 to that in 2000?
Your response must be concise. 0.94. What is the ratio of the Value added (constant 2005 US$) of Micronesia in 1998 to that in 2000?
Your response must be concise. 1.01. What is the ratio of the Value added (constant 2005 US$) in Panama in 1998 to that in 2000?
Make the answer very short. 0.9. What is the ratio of the Value added (constant 2005 US$) in East Asia (all income levels) in 1998 to that in 2001?
Give a very brief answer. 0.94. What is the ratio of the Value added (constant 2005 US$) of Mauritania in 1998 to that in 2001?
Give a very brief answer. 0.93. What is the ratio of the Value added (constant 2005 US$) of Micronesia in 1998 to that in 2001?
Your answer should be compact. 1.05. What is the ratio of the Value added (constant 2005 US$) in Panama in 1998 to that in 2001?
Provide a short and direct response. 0.84. What is the ratio of the Value added (constant 2005 US$) of East Asia (all income levels) in 1998 to that in 2002?
Your response must be concise. 0.91. What is the ratio of the Value added (constant 2005 US$) in Mauritania in 1998 to that in 2002?
Keep it short and to the point. 0.96. What is the ratio of the Value added (constant 2005 US$) of Micronesia in 1998 to that in 2002?
Your answer should be compact. 1.03. What is the ratio of the Value added (constant 2005 US$) of Panama in 1998 to that in 2002?
Ensure brevity in your answer.  0.81. What is the ratio of the Value added (constant 2005 US$) in East Asia (all income levels) in 1999 to that in 2000?
Give a very brief answer. 0.97. What is the ratio of the Value added (constant 2005 US$) of Micronesia in 1999 to that in 2000?
Provide a succinct answer. 0.94. What is the ratio of the Value added (constant 2005 US$) of Panama in 1999 to that in 2000?
Your answer should be compact. 0.91. What is the ratio of the Value added (constant 2005 US$) of East Asia (all income levels) in 1999 to that in 2001?
Provide a short and direct response. 0.97. What is the ratio of the Value added (constant 2005 US$) in Mauritania in 1999 to that in 2001?
Provide a short and direct response. 1. What is the ratio of the Value added (constant 2005 US$) of Micronesia in 1999 to that in 2001?
Your answer should be compact. 0.97. What is the ratio of the Value added (constant 2005 US$) in Panama in 1999 to that in 2001?
Offer a very short reply. 0.86. What is the ratio of the Value added (constant 2005 US$) in East Asia (all income levels) in 1999 to that in 2002?
Offer a very short reply. 0.94. What is the ratio of the Value added (constant 2005 US$) of Mauritania in 1999 to that in 2002?
Your response must be concise. 1.03. What is the ratio of the Value added (constant 2005 US$) in Micronesia in 1999 to that in 2002?
Give a very brief answer. 0.95. What is the ratio of the Value added (constant 2005 US$) of Panama in 1999 to that in 2002?
Offer a terse response. 0.83. What is the ratio of the Value added (constant 2005 US$) of Mauritania in 2000 to that in 2001?
Offer a terse response. 0.99. What is the ratio of the Value added (constant 2005 US$) of Micronesia in 2000 to that in 2001?
Provide a succinct answer. 1.03. What is the ratio of the Value added (constant 2005 US$) in Panama in 2000 to that in 2001?
Offer a very short reply. 0.94. What is the ratio of the Value added (constant 2005 US$) in East Asia (all income levels) in 2000 to that in 2002?
Provide a succinct answer. 0.96. What is the ratio of the Value added (constant 2005 US$) in Micronesia in 2000 to that in 2002?
Make the answer very short. 1.01. What is the ratio of the Value added (constant 2005 US$) of East Asia (all income levels) in 2001 to that in 2002?
Ensure brevity in your answer.  0.97. What is the ratio of the Value added (constant 2005 US$) in Mauritania in 2001 to that in 2002?
Keep it short and to the point. 1.03. What is the ratio of the Value added (constant 2005 US$) in Micronesia in 2001 to that in 2002?
Make the answer very short. 0.98. What is the ratio of the Value added (constant 2005 US$) in Panama in 2001 to that in 2002?
Offer a very short reply. 0.97. What is the difference between the highest and the second highest Value added (constant 2005 US$) in East Asia (all income levels)?
Offer a very short reply. 1.31e+1. What is the difference between the highest and the second highest Value added (constant 2005 US$) in Mauritania?
Your answer should be compact. 1.04e+08. What is the difference between the highest and the second highest Value added (constant 2005 US$) of Micronesia?
Your answer should be very brief. 7.99e+05. What is the difference between the highest and the second highest Value added (constant 2005 US$) in Panama?
Ensure brevity in your answer.  2.85e+07. What is the difference between the highest and the lowest Value added (constant 2005 US$) in East Asia (all income levels)?
Give a very brief answer. 5.42e+1. What is the difference between the highest and the lowest Value added (constant 2005 US$) in Mauritania?
Your response must be concise. 1.52e+08. What is the difference between the highest and the lowest Value added (constant 2005 US$) in Micronesia?
Give a very brief answer. 7.45e+06. What is the difference between the highest and the lowest Value added (constant 2005 US$) of Panama?
Ensure brevity in your answer.  2.31e+08. 